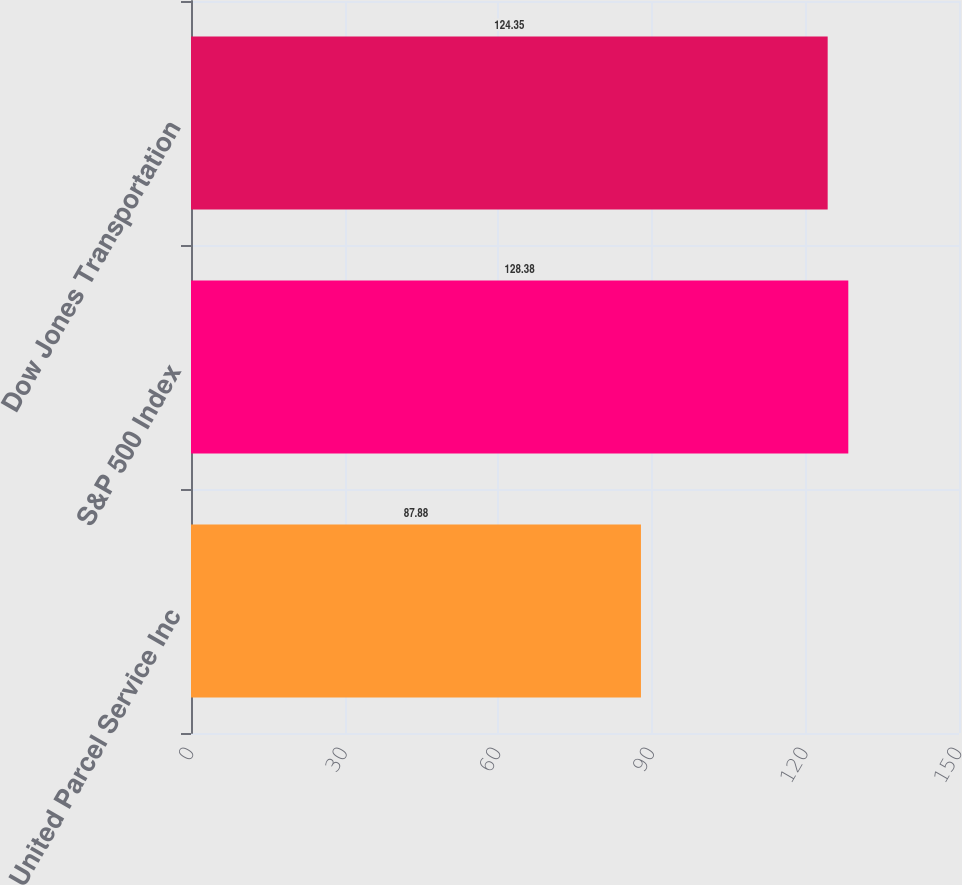Convert chart. <chart><loc_0><loc_0><loc_500><loc_500><bar_chart><fcel>United Parcel Service Inc<fcel>S&P 500 Index<fcel>Dow Jones Transportation<nl><fcel>87.88<fcel>128.38<fcel>124.35<nl></chart> 